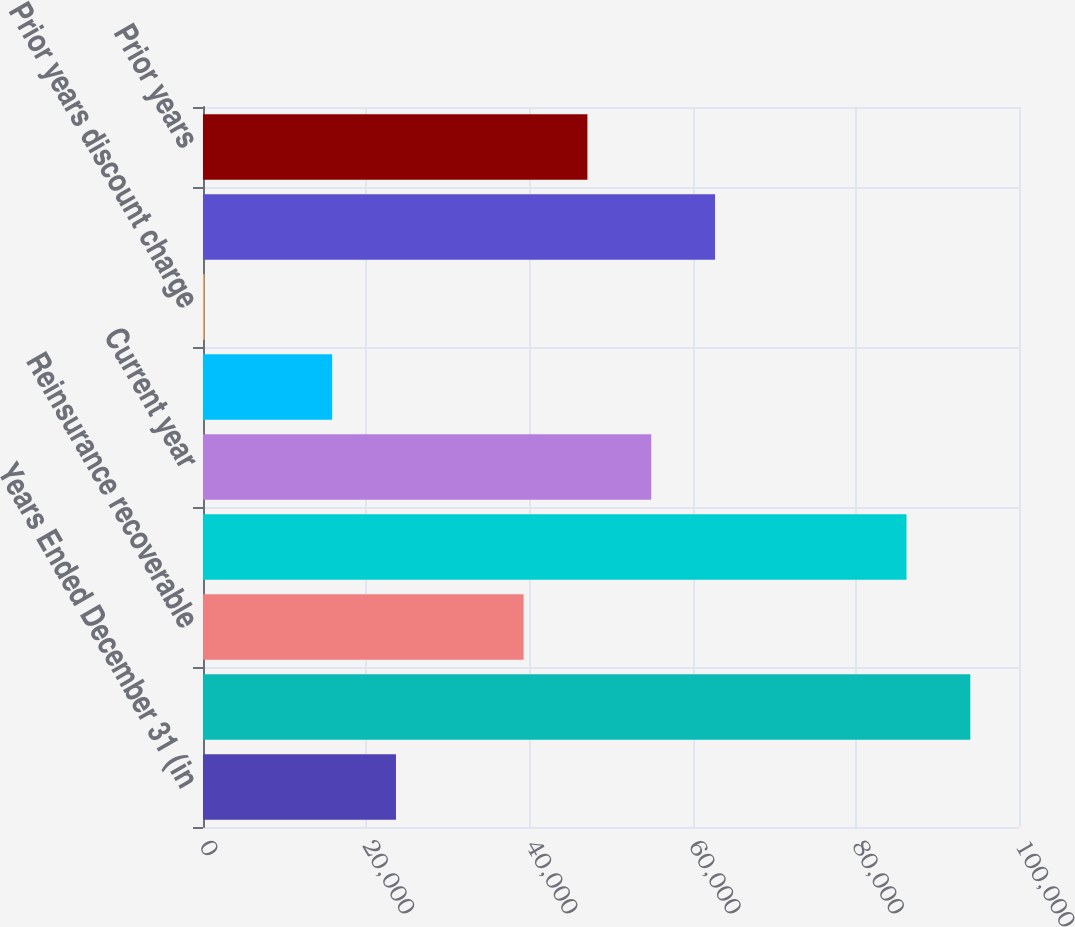Convert chart to OTSL. <chart><loc_0><loc_0><loc_500><loc_500><bar_chart><fcel>Years Ended December 31 (in<fcel>Liability for unpaid loss and<fcel>Reinsurance recoverable<fcel>Net Liability for unpaid loss<fcel>Current year<fcel>Prior years excluding discount<fcel>Prior years discount charge<fcel>Total losses and loss<fcel>Prior years<nl><fcel>23648.8<fcel>94034.2<fcel>39290<fcel>86213.6<fcel>54931.2<fcel>15828.2<fcel>187<fcel>62751.8<fcel>47110.6<nl></chart> 